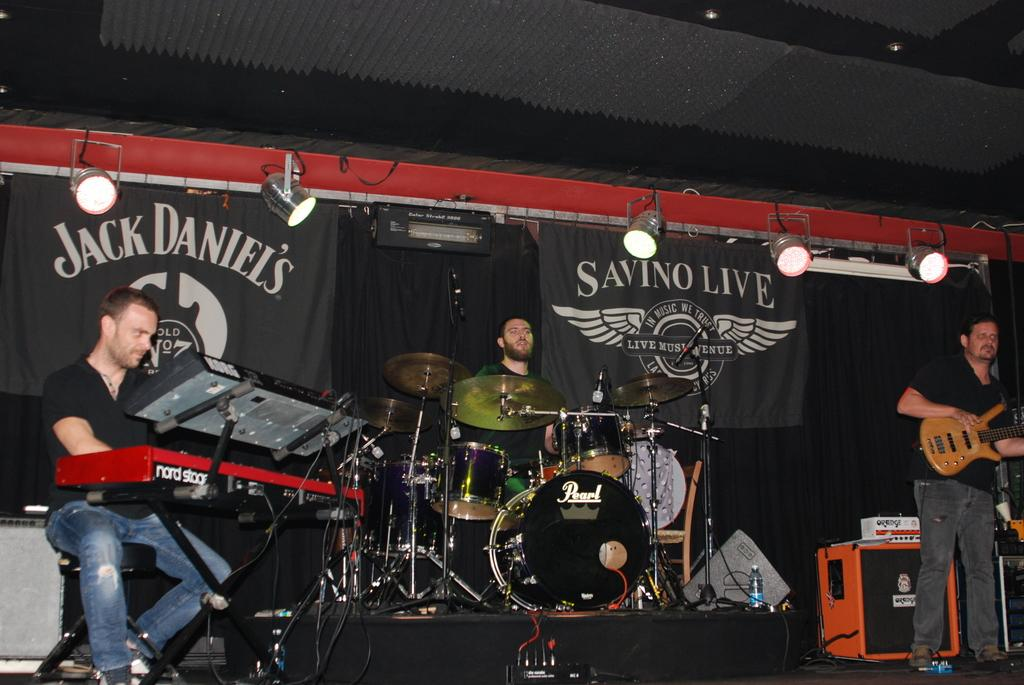How many people are in the image? There are three men in the image. What are the men doing in the image? All three men are playing musical instruments. What can be seen in the background of the image? There are curtains and lights visible in the background of the image. What type of fish is swimming in the background of the image? There is no fish present in the image; the background features curtains and lights. 